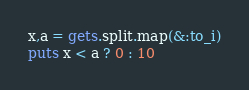<code> <loc_0><loc_0><loc_500><loc_500><_Ruby_>x,a = gets.split.map(&:to_i)
puts x < a ? 0 : 10
</code> 